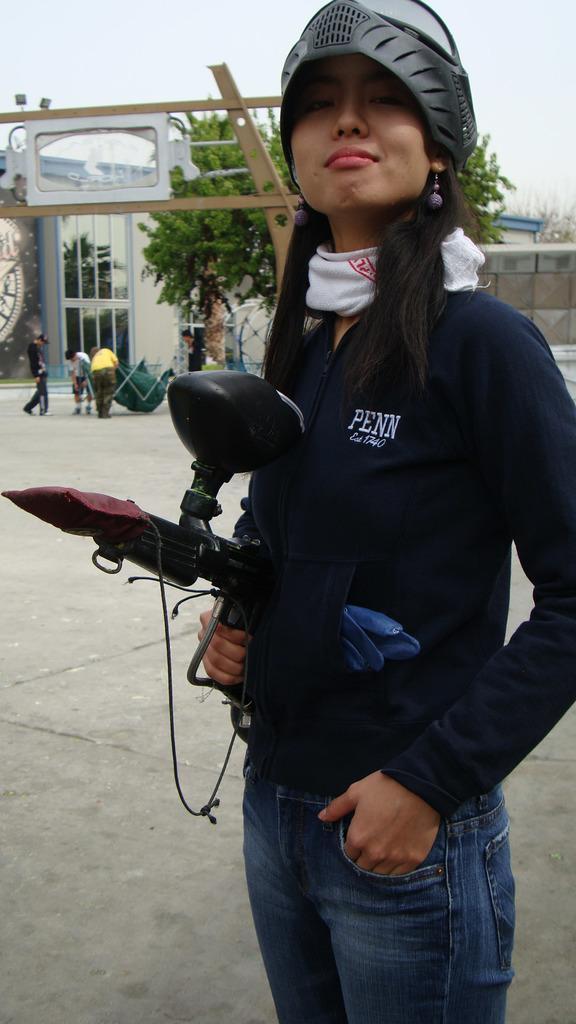Could you give a brief overview of what you see in this image? In the foreground of the picture there is a woman wearing a helmet and holding an object is standing. In the background there are trees, building, wall, gate and people. Sky is cloudy. 